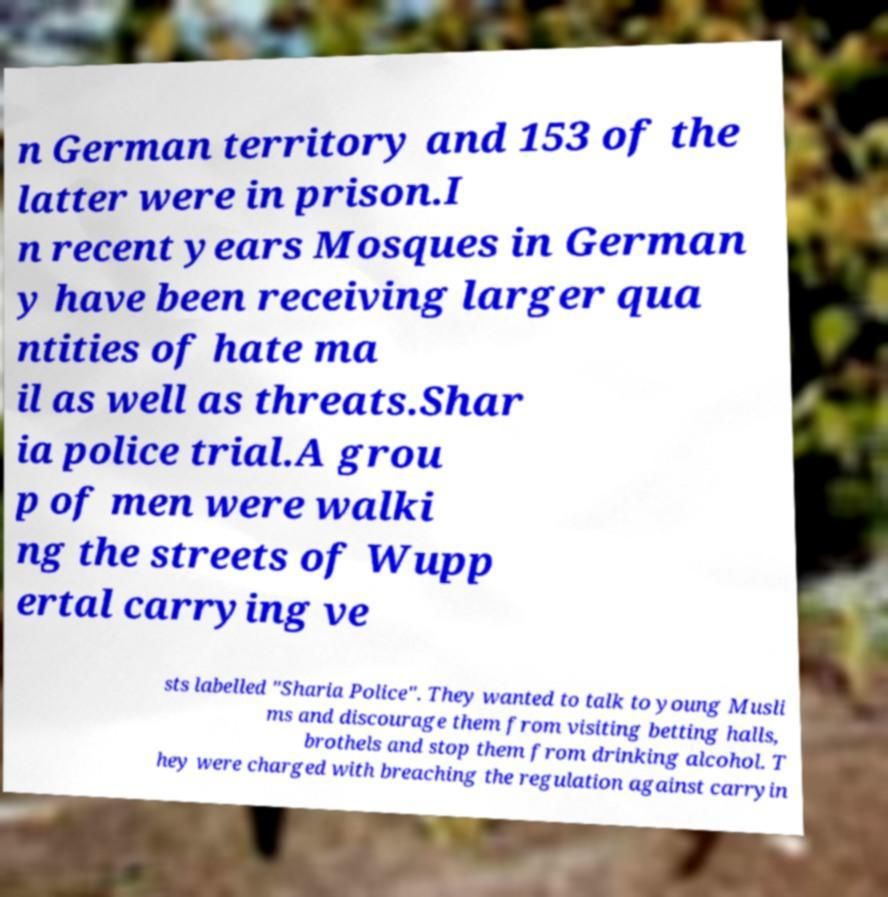For documentation purposes, I need the text within this image transcribed. Could you provide that? n German territory and 153 of the latter were in prison.I n recent years Mosques in German y have been receiving larger qua ntities of hate ma il as well as threats.Shar ia police trial.A grou p of men were walki ng the streets of Wupp ertal carrying ve sts labelled "Sharia Police". They wanted to talk to young Musli ms and discourage them from visiting betting halls, brothels and stop them from drinking alcohol. T hey were charged with breaching the regulation against carryin 